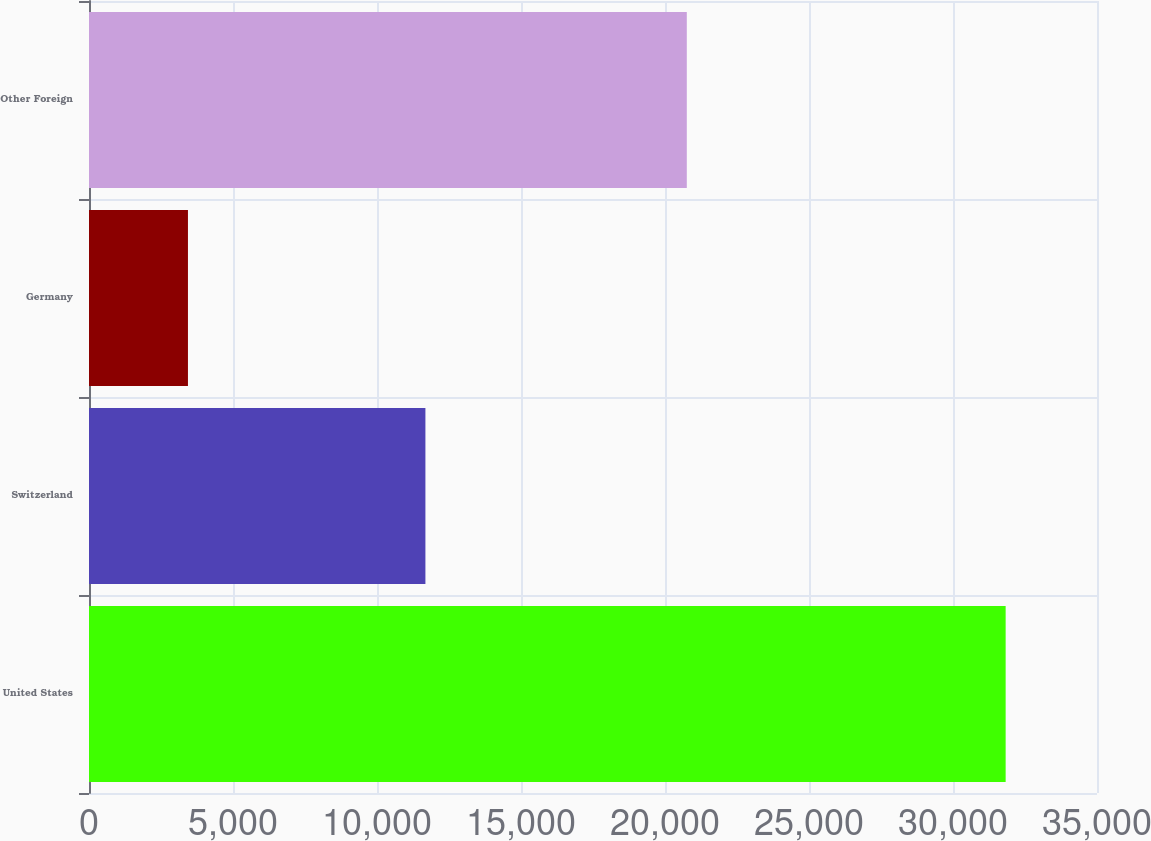<chart> <loc_0><loc_0><loc_500><loc_500><bar_chart><fcel>United States<fcel>Switzerland<fcel>Germany<fcel>Other Foreign<nl><fcel>31828<fcel>11681<fcel>3436<fcel>20757<nl></chart> 